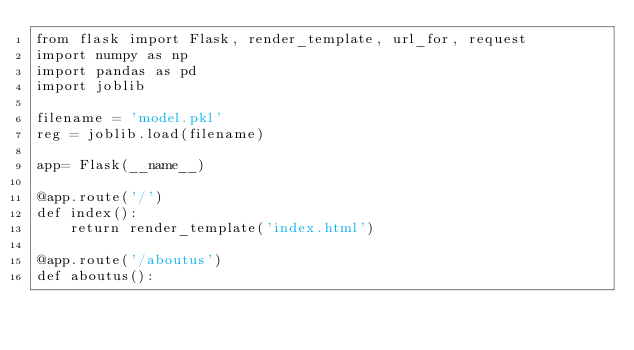Convert code to text. <code><loc_0><loc_0><loc_500><loc_500><_Python_>from flask import Flask, render_template, url_for, request
import numpy as np
import pandas as pd
import joblib
 
filename = 'model.pkl'
reg = joblib.load(filename)

app= Flask(__name__)

@app.route('/')
def index():
    return render_template('index.html')

@app.route('/aboutus')
def aboutus():</code> 